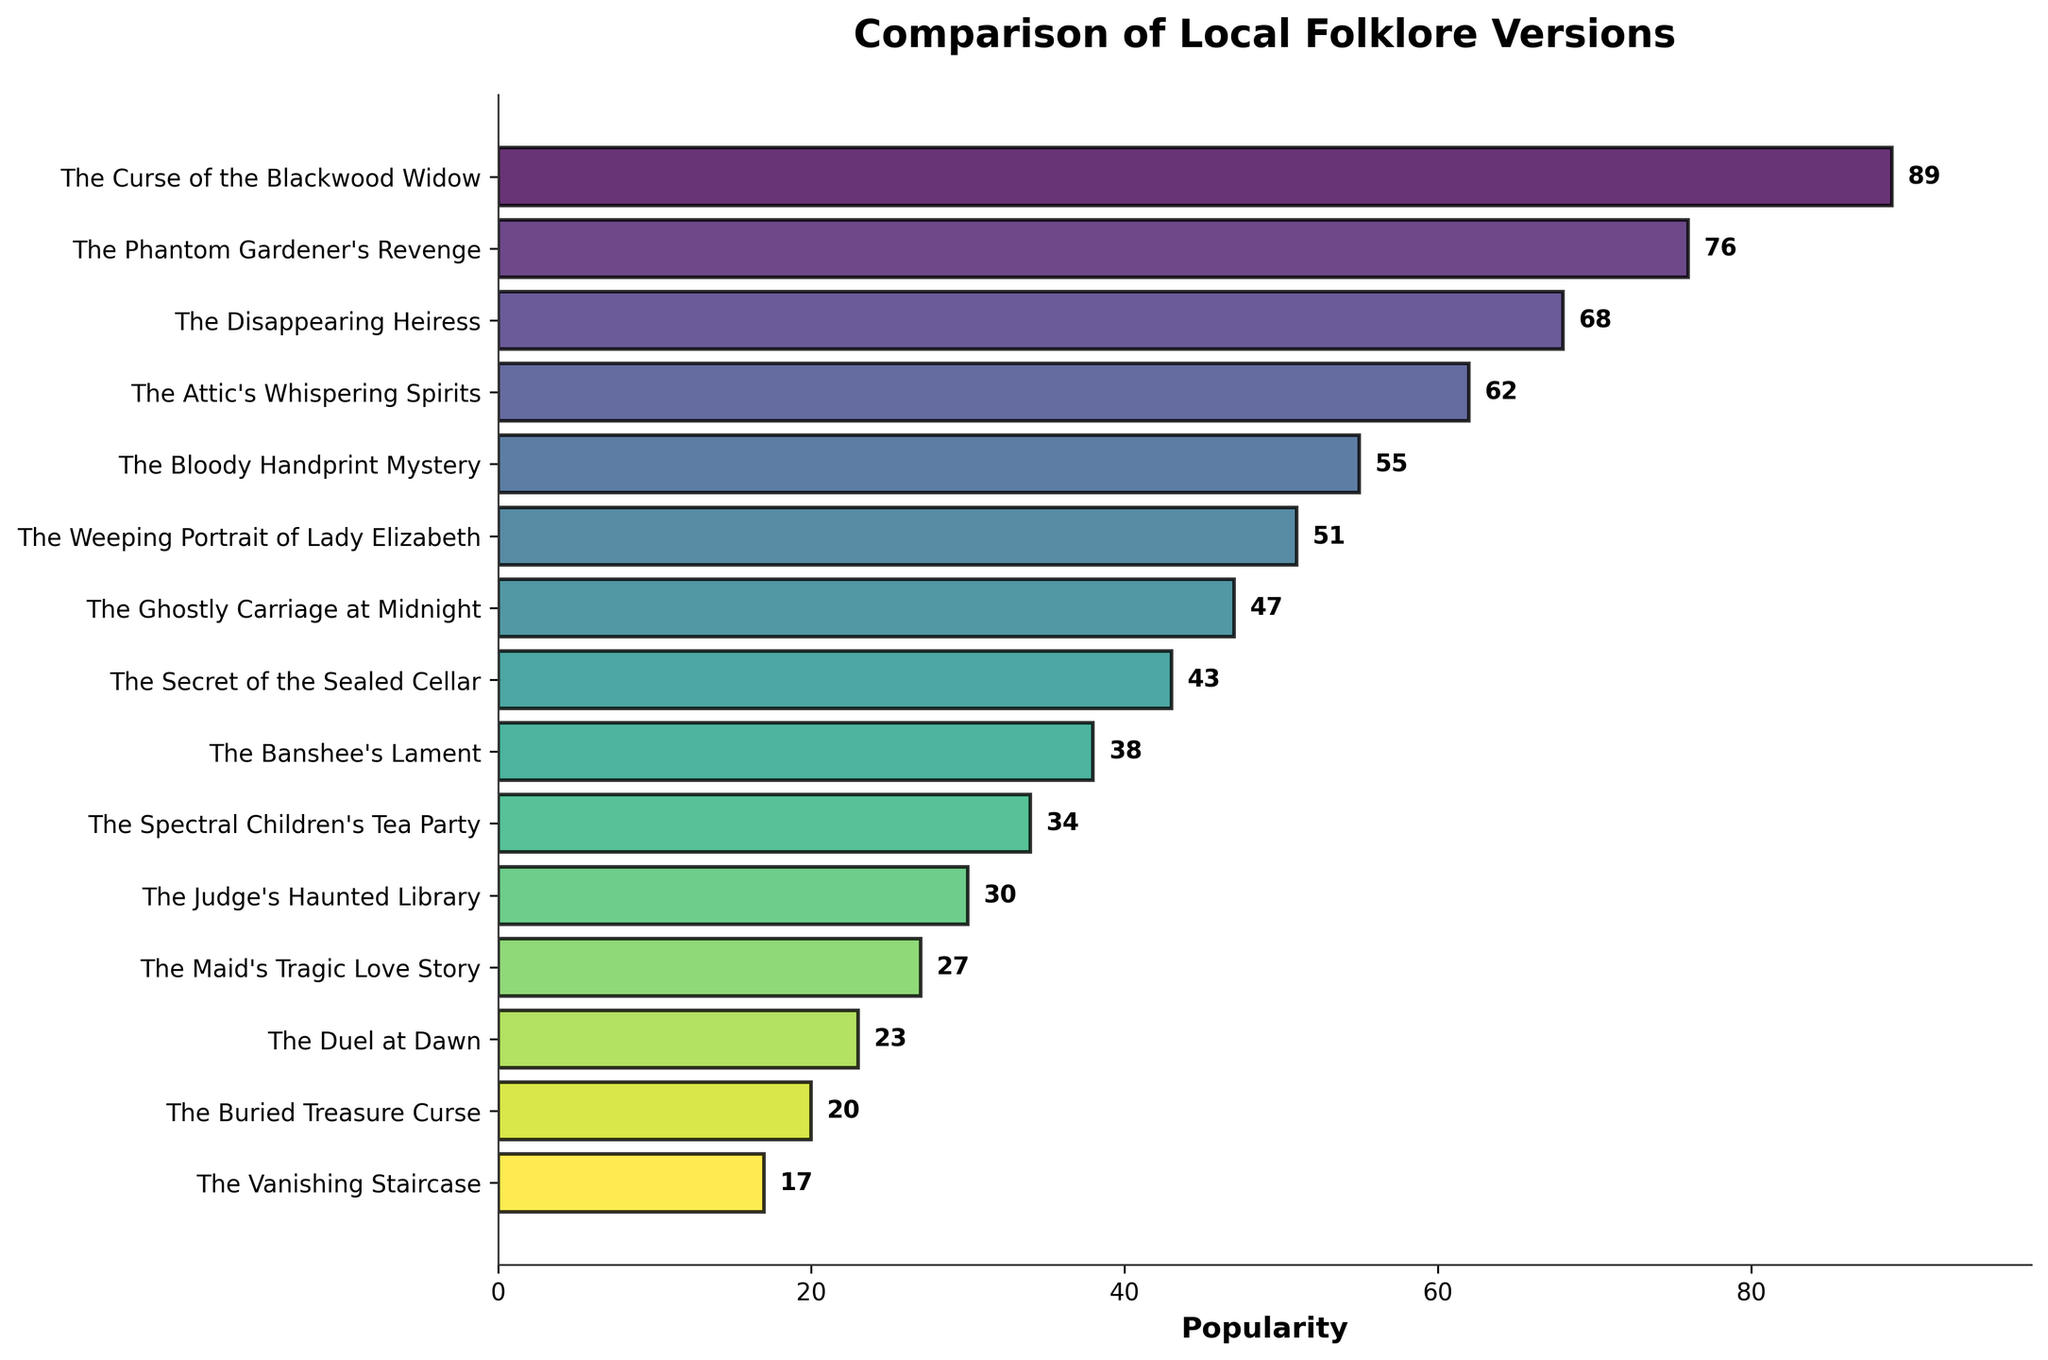What is the most popular folklore version according to the figure? The figure shows various folklore versions, each with a corresponding bar representing their popularity. The length of the bars indicates the popularity value. The longest bar represents "The Curse of the Blackwood Widow" with a value of 89.
Answer: The Curse of the Blackwood Widow How much more popular is "The Phantom Gardener's Revenge" than "The Banshee's Lament"? To find the difference in popularity, we subtract the popularity of "The Banshee's Lament" from "The Phantom Gardener's Revenge": 76 (Phantom Gardener) - 38 (Banshee's Lament) = 38.
Answer: 38 Which folklore version ranks third in popularity? By looking at the lengths of the bars in descending order, the third longest bar corresponds to "The Disappearing Heiress" with a popularity of 68.
Answer: The Disappearing Heiress What is the combined popularity of "The Attic's Whispering Spirits" and "The Bloody Handprint Mystery"? Add the popularity values of the two folklore versions: 62 (Attic's Whispering Spirits) + 55 (Bloody Handprint Mystery) = 117.
Answer: 117 How many folklore versions have a popularity score below 30? The figure shows bars with popularity values associated. Count the bars with values below 30: "The Judge's Haunted Library" (30), "The Maid's Tragic Love Story" (27), "The Duel at Dawn" (23), "The Buried Treasure Curse" (20), and "The Vanishing Staircase" (17). This gives us 5 versions.
Answer: 5 Which folklore version has a popularity closest to 50? By observing the bar lengths and checking the annotations, we see that "The Weeping Portrait of Lady Elizabeth" has a popularity value of 51, which is closest to 50.
Answer: The Weeping Portrait of Lady Elizabeth What is the average popularity of the top 5 most popular folklore versions? Identify the top 5 versions and sum their popularity values: 89 (Curse of the Blackwood Widow) + 76 (Phantom Gardener's Revenge) + 68 (Disappearing Heiress) + 62 (Attic's Whispering Spirits) + 55 (Bloody Handprint Mystery) = 350. Then, divide by 5 to get the average: 350 / 5 = 70.
Answer: 70 Which has a higher popularity, "The Secret of the Sealed Cellar" or "The Ghostly Carriage at Midnight"? Compare the popularity values directly: "The Ghostly Carriage at Midnight" has a popularity of 47, while "The Secret of the Sealed Cellar" has a popularity of 43.
Answer: The Ghostly Carriage at Midnight What is the difference in popularity between the least popular and the most popular folklore versions? Subtract the popularity of the least popular version from the most popular version: 89 (most popular) - 17 (least popular) = 72.
Answer: 72 